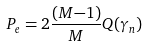<formula> <loc_0><loc_0><loc_500><loc_500>P _ { e } = 2 \frac { ( M { - } 1 ) } { M } Q ( \gamma _ { n } )</formula> 